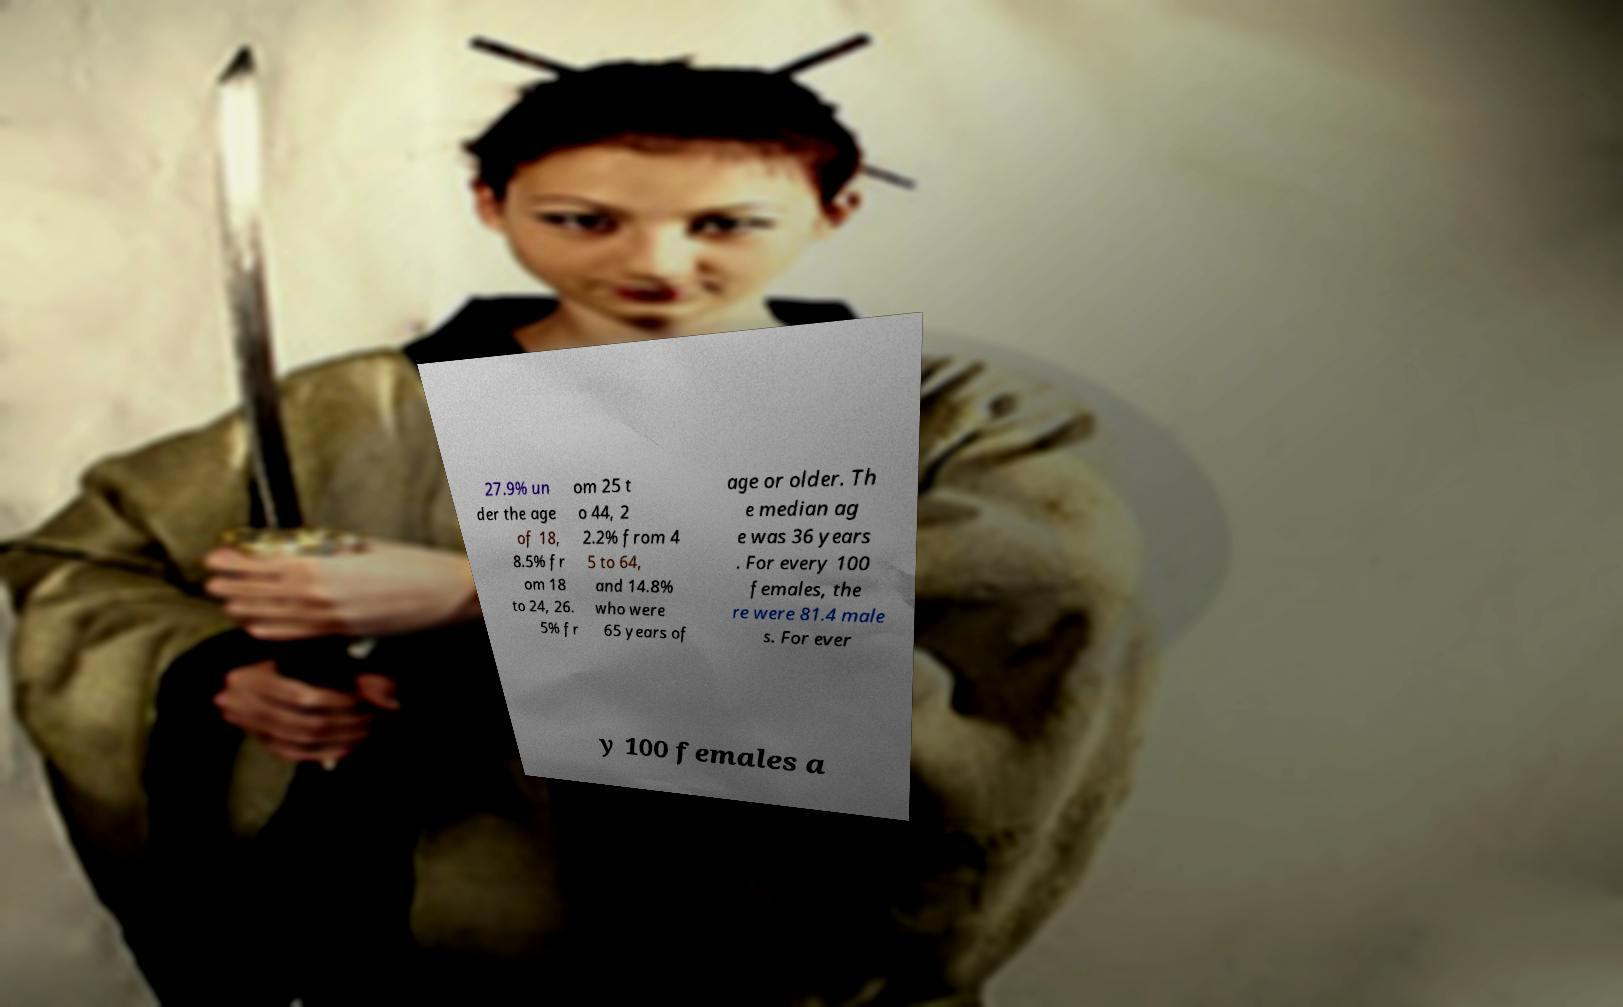Can you read and provide the text displayed in the image?This photo seems to have some interesting text. Can you extract and type it out for me? 27.9% un der the age of 18, 8.5% fr om 18 to 24, 26. 5% fr om 25 t o 44, 2 2.2% from 4 5 to 64, and 14.8% who were 65 years of age or older. Th e median ag e was 36 years . For every 100 females, the re were 81.4 male s. For ever y 100 females a 